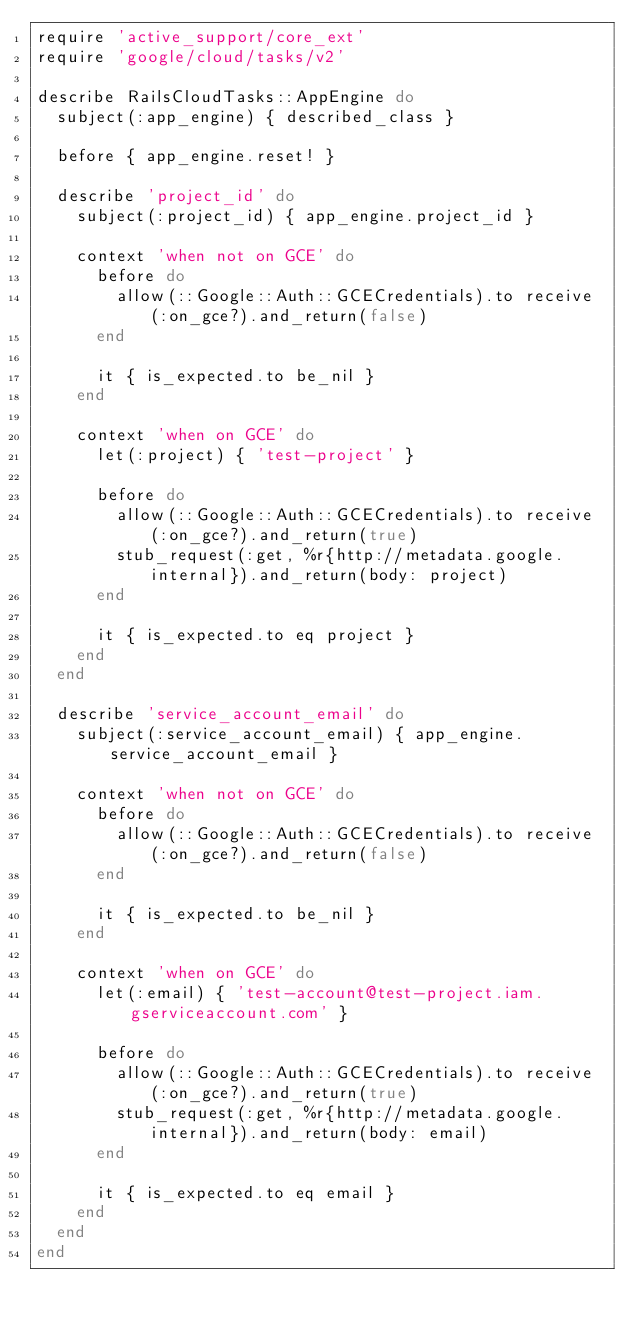<code> <loc_0><loc_0><loc_500><loc_500><_Ruby_>require 'active_support/core_ext'
require 'google/cloud/tasks/v2'

describe RailsCloudTasks::AppEngine do
  subject(:app_engine) { described_class }

  before { app_engine.reset! }

  describe 'project_id' do
    subject(:project_id) { app_engine.project_id }

    context 'when not on GCE' do
      before do
        allow(::Google::Auth::GCECredentials).to receive(:on_gce?).and_return(false)
      end

      it { is_expected.to be_nil }
    end

    context 'when on GCE' do
      let(:project) { 'test-project' }

      before do
        allow(::Google::Auth::GCECredentials).to receive(:on_gce?).and_return(true)
        stub_request(:get, %r{http://metadata.google.internal}).and_return(body: project)
      end

      it { is_expected.to eq project }
    end
  end

  describe 'service_account_email' do
    subject(:service_account_email) { app_engine.service_account_email }

    context 'when not on GCE' do
      before do
        allow(::Google::Auth::GCECredentials).to receive(:on_gce?).and_return(false)
      end

      it { is_expected.to be_nil }
    end

    context 'when on GCE' do
      let(:email) { 'test-account@test-project.iam.gserviceaccount.com' }

      before do
        allow(::Google::Auth::GCECredentials).to receive(:on_gce?).and_return(true)
        stub_request(:get, %r{http://metadata.google.internal}).and_return(body: email)
      end

      it { is_expected.to eq email }
    end
  end
end
</code> 